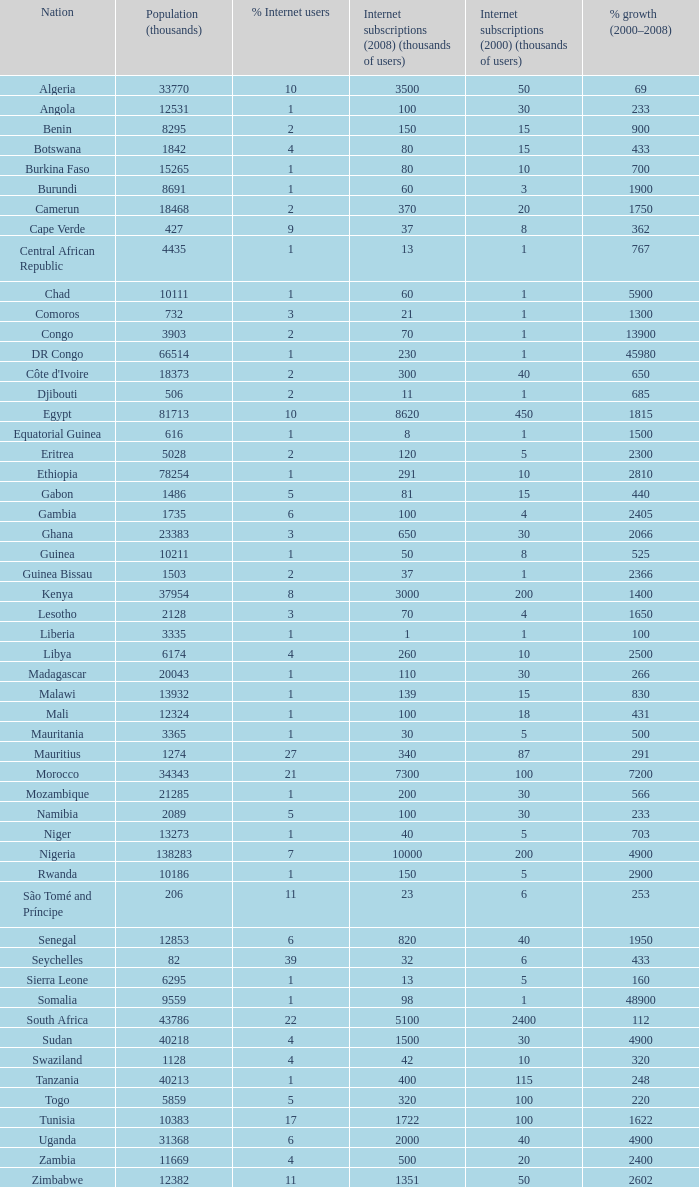Name the total number of percentage growth 2000-2008 of uganda? 1.0. 